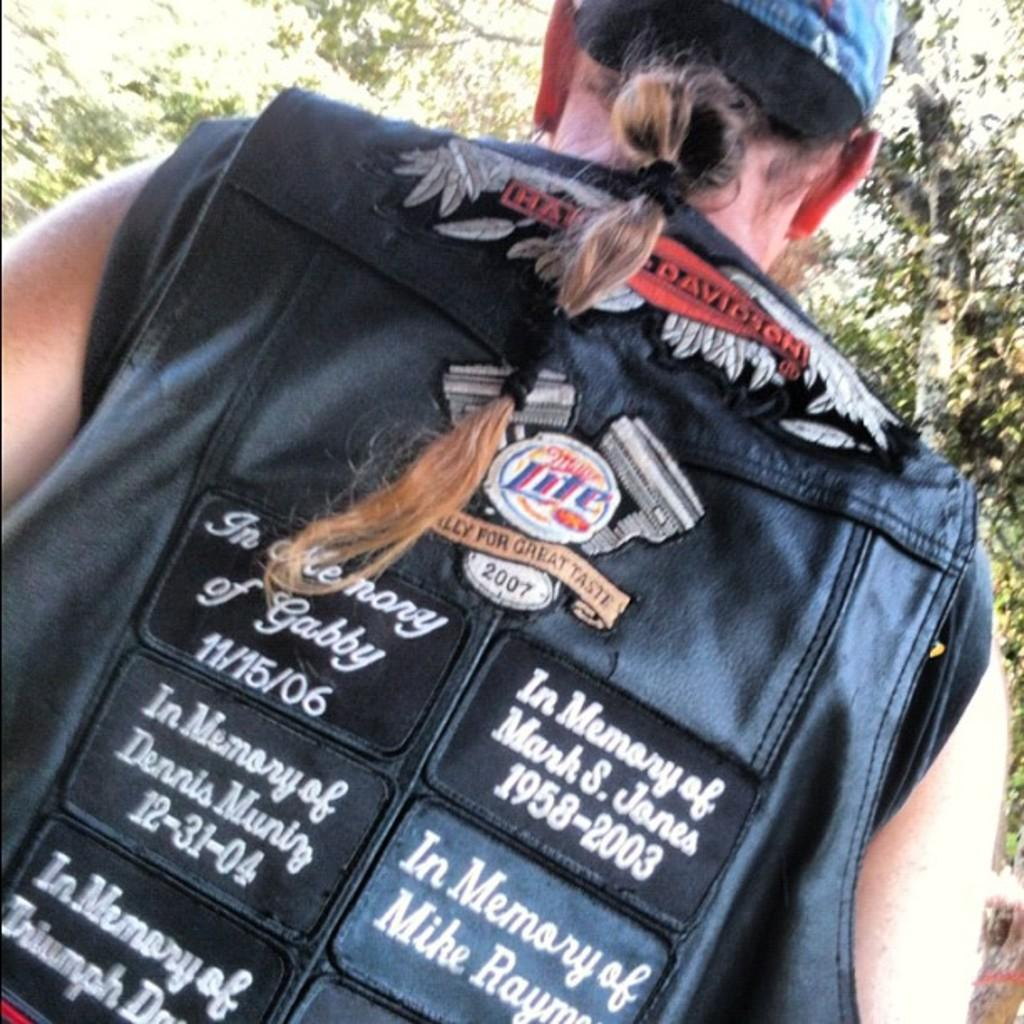What is the main subject of the image? There is a person standing in the image. What can be seen in the background of the image? There are trees in the background of the image. What type of berry can be seen growing on the person in the image? There are no berries present on the person in the image. What game is the person playing in the image? There is no game being played in the image; the person is simply standing. 